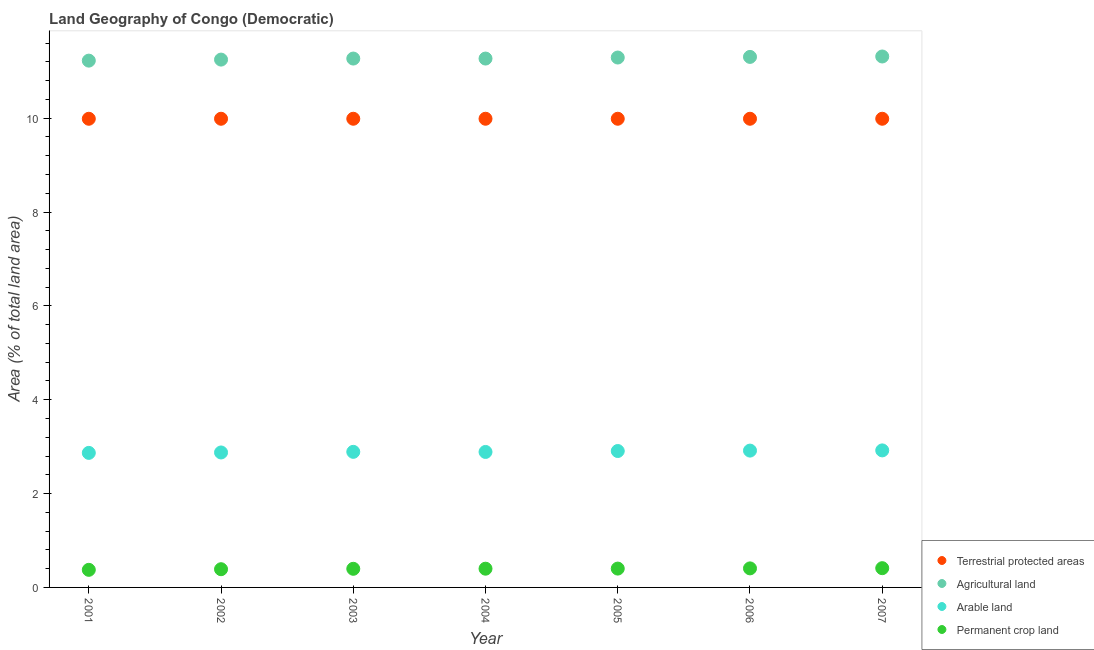What is the percentage of area under arable land in 2002?
Provide a short and direct response. 2.88. Across all years, what is the maximum percentage of area under agricultural land?
Give a very brief answer. 11.31. Across all years, what is the minimum percentage of area under agricultural land?
Offer a terse response. 11.23. In which year was the percentage of land under terrestrial protection maximum?
Provide a short and direct response. 2002. In which year was the percentage of area under agricultural land minimum?
Give a very brief answer. 2001. What is the total percentage of area under agricultural land in the graph?
Keep it short and to the point. 78.93. What is the difference between the percentage of land under terrestrial protection in 2001 and that in 2007?
Your response must be concise. -0. What is the difference between the percentage of land under terrestrial protection in 2006 and the percentage of area under permanent crop land in 2005?
Offer a terse response. 9.59. What is the average percentage of land under terrestrial protection per year?
Your response must be concise. 9.99. In the year 2003, what is the difference between the percentage of land under terrestrial protection and percentage of area under permanent crop land?
Provide a succinct answer. 9.59. In how many years, is the percentage of area under permanent crop land greater than 10 %?
Keep it short and to the point. 0. What is the ratio of the percentage of area under permanent crop land in 2002 to that in 2007?
Provide a short and direct response. 0.95. Is the difference between the percentage of area under agricultural land in 2003 and 2006 greater than the difference between the percentage of land under terrestrial protection in 2003 and 2006?
Offer a very short reply. No. What is the difference between the highest and the second highest percentage of area under agricultural land?
Ensure brevity in your answer.  0.01. What is the difference between the highest and the lowest percentage of area under agricultural land?
Your answer should be compact. 0.09. Is the sum of the percentage of area under arable land in 2003 and 2007 greater than the maximum percentage of area under agricultural land across all years?
Make the answer very short. No. Does the percentage of area under arable land monotonically increase over the years?
Offer a very short reply. No. Is the percentage of area under agricultural land strictly less than the percentage of land under terrestrial protection over the years?
Give a very brief answer. No. Are the values on the major ticks of Y-axis written in scientific E-notation?
Provide a succinct answer. No. Does the graph contain any zero values?
Your answer should be very brief. No. Does the graph contain grids?
Provide a succinct answer. No. Where does the legend appear in the graph?
Keep it short and to the point. Bottom right. How are the legend labels stacked?
Provide a short and direct response. Vertical. What is the title of the graph?
Keep it short and to the point. Land Geography of Congo (Democratic). What is the label or title of the Y-axis?
Provide a succinct answer. Area (% of total land area). What is the Area (% of total land area) of Terrestrial protected areas in 2001?
Offer a very short reply. 9.99. What is the Area (% of total land area) in Agricultural land in 2001?
Provide a succinct answer. 11.23. What is the Area (% of total land area) of Arable land in 2001?
Provide a short and direct response. 2.87. What is the Area (% of total land area) in Permanent crop land in 2001?
Ensure brevity in your answer.  0.37. What is the Area (% of total land area) in Terrestrial protected areas in 2002?
Provide a short and direct response. 9.99. What is the Area (% of total land area) in Agricultural land in 2002?
Offer a terse response. 11.25. What is the Area (% of total land area) of Arable land in 2002?
Give a very brief answer. 2.88. What is the Area (% of total land area) in Permanent crop land in 2002?
Your response must be concise. 0.39. What is the Area (% of total land area) in Terrestrial protected areas in 2003?
Provide a short and direct response. 9.99. What is the Area (% of total land area) in Agricultural land in 2003?
Make the answer very short. 11.27. What is the Area (% of total land area) in Arable land in 2003?
Offer a very short reply. 2.89. What is the Area (% of total land area) in Permanent crop land in 2003?
Your response must be concise. 0.4. What is the Area (% of total land area) of Terrestrial protected areas in 2004?
Your answer should be very brief. 9.99. What is the Area (% of total land area) of Agricultural land in 2004?
Make the answer very short. 11.27. What is the Area (% of total land area) in Arable land in 2004?
Your answer should be very brief. 2.89. What is the Area (% of total land area) of Permanent crop land in 2004?
Your answer should be very brief. 0.4. What is the Area (% of total land area) of Terrestrial protected areas in 2005?
Offer a very short reply. 9.99. What is the Area (% of total land area) of Agricultural land in 2005?
Your answer should be compact. 11.29. What is the Area (% of total land area) in Arable land in 2005?
Make the answer very short. 2.91. What is the Area (% of total land area) in Permanent crop land in 2005?
Provide a short and direct response. 0.4. What is the Area (% of total land area) of Terrestrial protected areas in 2006?
Make the answer very short. 9.99. What is the Area (% of total land area) of Agricultural land in 2006?
Provide a succinct answer. 11.31. What is the Area (% of total land area) of Arable land in 2006?
Offer a very short reply. 2.92. What is the Area (% of total land area) in Permanent crop land in 2006?
Make the answer very short. 0.41. What is the Area (% of total land area) in Terrestrial protected areas in 2007?
Provide a short and direct response. 9.99. What is the Area (% of total land area) of Agricultural land in 2007?
Give a very brief answer. 11.31. What is the Area (% of total land area) of Arable land in 2007?
Offer a very short reply. 2.92. What is the Area (% of total land area) in Permanent crop land in 2007?
Ensure brevity in your answer.  0.41. Across all years, what is the maximum Area (% of total land area) in Terrestrial protected areas?
Provide a succinct answer. 9.99. Across all years, what is the maximum Area (% of total land area) in Agricultural land?
Provide a succinct answer. 11.31. Across all years, what is the maximum Area (% of total land area) in Arable land?
Give a very brief answer. 2.92. Across all years, what is the maximum Area (% of total land area) in Permanent crop land?
Offer a very short reply. 0.41. Across all years, what is the minimum Area (% of total land area) of Terrestrial protected areas?
Your answer should be very brief. 9.99. Across all years, what is the minimum Area (% of total land area) in Agricultural land?
Ensure brevity in your answer.  11.23. Across all years, what is the minimum Area (% of total land area) in Arable land?
Keep it short and to the point. 2.87. Across all years, what is the minimum Area (% of total land area) of Permanent crop land?
Offer a terse response. 0.37. What is the total Area (% of total land area) in Terrestrial protected areas in the graph?
Provide a short and direct response. 69.91. What is the total Area (% of total land area) in Agricultural land in the graph?
Ensure brevity in your answer.  78.93. What is the total Area (% of total land area) of Arable land in the graph?
Your response must be concise. 20.26. What is the total Area (% of total land area) of Permanent crop land in the graph?
Keep it short and to the point. 2.78. What is the difference between the Area (% of total land area) of Terrestrial protected areas in 2001 and that in 2002?
Offer a very short reply. -0. What is the difference between the Area (% of total land area) in Agricultural land in 2001 and that in 2002?
Offer a terse response. -0.02. What is the difference between the Area (% of total land area) in Arable land in 2001 and that in 2002?
Give a very brief answer. -0.01. What is the difference between the Area (% of total land area) in Permanent crop land in 2001 and that in 2002?
Give a very brief answer. -0.01. What is the difference between the Area (% of total land area) in Terrestrial protected areas in 2001 and that in 2003?
Make the answer very short. -0. What is the difference between the Area (% of total land area) in Agricultural land in 2001 and that in 2003?
Give a very brief answer. -0.04. What is the difference between the Area (% of total land area) of Arable land in 2001 and that in 2003?
Keep it short and to the point. -0.02. What is the difference between the Area (% of total land area) in Permanent crop land in 2001 and that in 2003?
Make the answer very short. -0.02. What is the difference between the Area (% of total land area) of Terrestrial protected areas in 2001 and that in 2004?
Your answer should be compact. -0. What is the difference between the Area (% of total land area) of Agricultural land in 2001 and that in 2004?
Your answer should be compact. -0.04. What is the difference between the Area (% of total land area) of Arable land in 2001 and that in 2004?
Your answer should be compact. -0.02. What is the difference between the Area (% of total land area) in Permanent crop land in 2001 and that in 2004?
Keep it short and to the point. -0.02. What is the difference between the Area (% of total land area) of Terrestrial protected areas in 2001 and that in 2005?
Your response must be concise. -0. What is the difference between the Area (% of total land area) of Agricultural land in 2001 and that in 2005?
Provide a short and direct response. -0.07. What is the difference between the Area (% of total land area) of Arable land in 2001 and that in 2005?
Your answer should be very brief. -0.04. What is the difference between the Area (% of total land area) of Permanent crop land in 2001 and that in 2005?
Give a very brief answer. -0.03. What is the difference between the Area (% of total land area) in Terrestrial protected areas in 2001 and that in 2006?
Make the answer very short. -0. What is the difference between the Area (% of total land area) of Agricultural land in 2001 and that in 2006?
Your answer should be very brief. -0.08. What is the difference between the Area (% of total land area) of Arable land in 2001 and that in 2006?
Offer a very short reply. -0.05. What is the difference between the Area (% of total land area) of Permanent crop land in 2001 and that in 2006?
Your response must be concise. -0.03. What is the difference between the Area (% of total land area) of Terrestrial protected areas in 2001 and that in 2007?
Your answer should be very brief. -0. What is the difference between the Area (% of total land area) in Agricultural land in 2001 and that in 2007?
Make the answer very short. -0.09. What is the difference between the Area (% of total land area) of Arable land in 2001 and that in 2007?
Your response must be concise. -0.05. What is the difference between the Area (% of total land area) in Permanent crop land in 2001 and that in 2007?
Your answer should be compact. -0.04. What is the difference between the Area (% of total land area) in Terrestrial protected areas in 2002 and that in 2003?
Ensure brevity in your answer.  0. What is the difference between the Area (% of total land area) in Agricultural land in 2002 and that in 2003?
Your response must be concise. -0.02. What is the difference between the Area (% of total land area) of Arable land in 2002 and that in 2003?
Your response must be concise. -0.01. What is the difference between the Area (% of total land area) in Permanent crop land in 2002 and that in 2003?
Your answer should be very brief. -0.01. What is the difference between the Area (% of total land area) in Terrestrial protected areas in 2002 and that in 2004?
Provide a short and direct response. 0. What is the difference between the Area (% of total land area) of Agricultural land in 2002 and that in 2004?
Give a very brief answer. -0.02. What is the difference between the Area (% of total land area) of Arable land in 2002 and that in 2004?
Provide a succinct answer. -0.01. What is the difference between the Area (% of total land area) of Permanent crop land in 2002 and that in 2004?
Give a very brief answer. -0.01. What is the difference between the Area (% of total land area) in Agricultural land in 2002 and that in 2005?
Make the answer very short. -0.04. What is the difference between the Area (% of total land area) of Arable land in 2002 and that in 2005?
Ensure brevity in your answer.  -0.03. What is the difference between the Area (% of total land area) of Permanent crop land in 2002 and that in 2005?
Offer a terse response. -0.01. What is the difference between the Area (% of total land area) of Terrestrial protected areas in 2002 and that in 2006?
Your response must be concise. 0. What is the difference between the Area (% of total land area) in Agricultural land in 2002 and that in 2006?
Provide a short and direct response. -0.06. What is the difference between the Area (% of total land area) of Arable land in 2002 and that in 2006?
Provide a short and direct response. -0.04. What is the difference between the Area (% of total land area) in Permanent crop land in 2002 and that in 2006?
Your answer should be compact. -0.02. What is the difference between the Area (% of total land area) in Terrestrial protected areas in 2002 and that in 2007?
Ensure brevity in your answer.  0. What is the difference between the Area (% of total land area) of Agricultural land in 2002 and that in 2007?
Ensure brevity in your answer.  -0.07. What is the difference between the Area (% of total land area) in Arable land in 2002 and that in 2007?
Your answer should be compact. -0.04. What is the difference between the Area (% of total land area) of Permanent crop land in 2002 and that in 2007?
Make the answer very short. -0.02. What is the difference between the Area (% of total land area) in Arable land in 2003 and that in 2004?
Offer a very short reply. 0. What is the difference between the Area (% of total land area) in Permanent crop land in 2003 and that in 2004?
Your response must be concise. -0. What is the difference between the Area (% of total land area) of Agricultural land in 2003 and that in 2005?
Offer a very short reply. -0.02. What is the difference between the Area (% of total land area) in Arable land in 2003 and that in 2005?
Keep it short and to the point. -0.02. What is the difference between the Area (% of total land area) of Permanent crop land in 2003 and that in 2005?
Make the answer very short. -0. What is the difference between the Area (% of total land area) of Terrestrial protected areas in 2003 and that in 2006?
Offer a terse response. 0. What is the difference between the Area (% of total land area) in Agricultural land in 2003 and that in 2006?
Offer a terse response. -0.04. What is the difference between the Area (% of total land area) in Arable land in 2003 and that in 2006?
Keep it short and to the point. -0.03. What is the difference between the Area (% of total land area) of Permanent crop land in 2003 and that in 2006?
Make the answer very short. -0.01. What is the difference between the Area (% of total land area) of Terrestrial protected areas in 2003 and that in 2007?
Keep it short and to the point. 0. What is the difference between the Area (% of total land area) in Agricultural land in 2003 and that in 2007?
Offer a very short reply. -0.04. What is the difference between the Area (% of total land area) of Arable land in 2003 and that in 2007?
Your answer should be compact. -0.03. What is the difference between the Area (% of total land area) of Permanent crop land in 2003 and that in 2007?
Offer a terse response. -0.01. What is the difference between the Area (% of total land area) of Terrestrial protected areas in 2004 and that in 2005?
Your response must be concise. 0. What is the difference between the Area (% of total land area) in Agricultural land in 2004 and that in 2005?
Your response must be concise. -0.02. What is the difference between the Area (% of total land area) in Arable land in 2004 and that in 2005?
Your answer should be very brief. -0.02. What is the difference between the Area (% of total land area) in Permanent crop land in 2004 and that in 2005?
Ensure brevity in your answer.  -0. What is the difference between the Area (% of total land area) in Agricultural land in 2004 and that in 2006?
Provide a succinct answer. -0.04. What is the difference between the Area (% of total land area) in Arable land in 2004 and that in 2006?
Provide a short and direct response. -0.03. What is the difference between the Area (% of total land area) of Permanent crop land in 2004 and that in 2006?
Provide a succinct answer. -0.01. What is the difference between the Area (% of total land area) in Terrestrial protected areas in 2004 and that in 2007?
Provide a succinct answer. 0. What is the difference between the Area (% of total land area) of Agricultural land in 2004 and that in 2007?
Your answer should be compact. -0.04. What is the difference between the Area (% of total land area) in Arable land in 2004 and that in 2007?
Your response must be concise. -0.03. What is the difference between the Area (% of total land area) in Permanent crop land in 2004 and that in 2007?
Provide a short and direct response. -0.01. What is the difference between the Area (% of total land area) in Terrestrial protected areas in 2005 and that in 2006?
Your response must be concise. 0. What is the difference between the Area (% of total land area) in Agricultural land in 2005 and that in 2006?
Keep it short and to the point. -0.01. What is the difference between the Area (% of total land area) of Arable land in 2005 and that in 2006?
Offer a very short reply. -0.01. What is the difference between the Area (% of total land area) of Permanent crop land in 2005 and that in 2006?
Your answer should be compact. -0. What is the difference between the Area (% of total land area) of Terrestrial protected areas in 2005 and that in 2007?
Keep it short and to the point. 0. What is the difference between the Area (% of total land area) of Agricultural land in 2005 and that in 2007?
Offer a very short reply. -0.02. What is the difference between the Area (% of total land area) in Arable land in 2005 and that in 2007?
Give a very brief answer. -0.01. What is the difference between the Area (% of total land area) of Permanent crop land in 2005 and that in 2007?
Offer a terse response. -0.01. What is the difference between the Area (% of total land area) of Terrestrial protected areas in 2006 and that in 2007?
Keep it short and to the point. 0. What is the difference between the Area (% of total land area) in Agricultural land in 2006 and that in 2007?
Provide a short and direct response. -0.01. What is the difference between the Area (% of total land area) in Arable land in 2006 and that in 2007?
Your answer should be compact. -0. What is the difference between the Area (% of total land area) of Permanent crop land in 2006 and that in 2007?
Make the answer very short. -0. What is the difference between the Area (% of total land area) of Terrestrial protected areas in 2001 and the Area (% of total land area) of Agricultural land in 2002?
Keep it short and to the point. -1.26. What is the difference between the Area (% of total land area) in Terrestrial protected areas in 2001 and the Area (% of total land area) in Arable land in 2002?
Make the answer very short. 7.11. What is the difference between the Area (% of total land area) of Terrestrial protected areas in 2001 and the Area (% of total land area) of Permanent crop land in 2002?
Offer a very short reply. 9.6. What is the difference between the Area (% of total land area) in Agricultural land in 2001 and the Area (% of total land area) in Arable land in 2002?
Make the answer very short. 8.35. What is the difference between the Area (% of total land area) of Agricultural land in 2001 and the Area (% of total land area) of Permanent crop land in 2002?
Offer a terse response. 10.84. What is the difference between the Area (% of total land area) of Arable land in 2001 and the Area (% of total land area) of Permanent crop land in 2002?
Provide a succinct answer. 2.48. What is the difference between the Area (% of total land area) of Terrestrial protected areas in 2001 and the Area (% of total land area) of Agricultural land in 2003?
Provide a succinct answer. -1.28. What is the difference between the Area (% of total land area) of Terrestrial protected areas in 2001 and the Area (% of total land area) of Arable land in 2003?
Your response must be concise. 7.1. What is the difference between the Area (% of total land area) of Terrestrial protected areas in 2001 and the Area (% of total land area) of Permanent crop land in 2003?
Your response must be concise. 9.59. What is the difference between the Area (% of total land area) of Agricultural land in 2001 and the Area (% of total land area) of Arable land in 2003?
Keep it short and to the point. 8.34. What is the difference between the Area (% of total land area) of Agricultural land in 2001 and the Area (% of total land area) of Permanent crop land in 2003?
Offer a terse response. 10.83. What is the difference between the Area (% of total land area) in Arable land in 2001 and the Area (% of total land area) in Permanent crop land in 2003?
Give a very brief answer. 2.47. What is the difference between the Area (% of total land area) in Terrestrial protected areas in 2001 and the Area (% of total land area) in Agricultural land in 2004?
Make the answer very short. -1.28. What is the difference between the Area (% of total land area) in Terrestrial protected areas in 2001 and the Area (% of total land area) in Arable land in 2004?
Ensure brevity in your answer.  7.1. What is the difference between the Area (% of total land area) of Terrestrial protected areas in 2001 and the Area (% of total land area) of Permanent crop land in 2004?
Provide a succinct answer. 9.59. What is the difference between the Area (% of total land area) in Agricultural land in 2001 and the Area (% of total land area) in Arable land in 2004?
Keep it short and to the point. 8.34. What is the difference between the Area (% of total land area) in Agricultural land in 2001 and the Area (% of total land area) in Permanent crop land in 2004?
Your answer should be compact. 10.83. What is the difference between the Area (% of total land area) of Arable land in 2001 and the Area (% of total land area) of Permanent crop land in 2004?
Your response must be concise. 2.47. What is the difference between the Area (% of total land area) of Terrestrial protected areas in 2001 and the Area (% of total land area) of Agricultural land in 2005?
Offer a very short reply. -1.31. What is the difference between the Area (% of total land area) in Terrestrial protected areas in 2001 and the Area (% of total land area) in Arable land in 2005?
Your answer should be compact. 7.08. What is the difference between the Area (% of total land area) of Terrestrial protected areas in 2001 and the Area (% of total land area) of Permanent crop land in 2005?
Offer a terse response. 9.59. What is the difference between the Area (% of total land area) of Agricultural land in 2001 and the Area (% of total land area) of Arable land in 2005?
Provide a succinct answer. 8.32. What is the difference between the Area (% of total land area) of Agricultural land in 2001 and the Area (% of total land area) of Permanent crop land in 2005?
Make the answer very short. 10.82. What is the difference between the Area (% of total land area) in Arable land in 2001 and the Area (% of total land area) in Permanent crop land in 2005?
Make the answer very short. 2.47. What is the difference between the Area (% of total land area) of Terrestrial protected areas in 2001 and the Area (% of total land area) of Agricultural land in 2006?
Offer a very short reply. -1.32. What is the difference between the Area (% of total land area) of Terrestrial protected areas in 2001 and the Area (% of total land area) of Arable land in 2006?
Your answer should be compact. 7.07. What is the difference between the Area (% of total land area) in Terrestrial protected areas in 2001 and the Area (% of total land area) in Permanent crop land in 2006?
Your answer should be very brief. 9.58. What is the difference between the Area (% of total land area) of Agricultural land in 2001 and the Area (% of total land area) of Arable land in 2006?
Provide a short and direct response. 8.31. What is the difference between the Area (% of total land area) in Agricultural land in 2001 and the Area (% of total land area) in Permanent crop land in 2006?
Your answer should be very brief. 10.82. What is the difference between the Area (% of total land area) of Arable land in 2001 and the Area (% of total land area) of Permanent crop land in 2006?
Keep it short and to the point. 2.46. What is the difference between the Area (% of total land area) of Terrestrial protected areas in 2001 and the Area (% of total land area) of Agricultural land in 2007?
Ensure brevity in your answer.  -1.33. What is the difference between the Area (% of total land area) of Terrestrial protected areas in 2001 and the Area (% of total land area) of Arable land in 2007?
Give a very brief answer. 7.07. What is the difference between the Area (% of total land area) in Terrestrial protected areas in 2001 and the Area (% of total land area) in Permanent crop land in 2007?
Offer a terse response. 9.58. What is the difference between the Area (% of total land area) in Agricultural land in 2001 and the Area (% of total land area) in Arable land in 2007?
Provide a short and direct response. 8.31. What is the difference between the Area (% of total land area) of Agricultural land in 2001 and the Area (% of total land area) of Permanent crop land in 2007?
Ensure brevity in your answer.  10.82. What is the difference between the Area (% of total land area) of Arable land in 2001 and the Area (% of total land area) of Permanent crop land in 2007?
Your response must be concise. 2.46. What is the difference between the Area (% of total land area) in Terrestrial protected areas in 2002 and the Area (% of total land area) in Agricultural land in 2003?
Provide a short and direct response. -1.28. What is the difference between the Area (% of total land area) in Terrestrial protected areas in 2002 and the Area (% of total land area) in Arable land in 2003?
Provide a short and direct response. 7.1. What is the difference between the Area (% of total land area) of Terrestrial protected areas in 2002 and the Area (% of total land area) of Permanent crop land in 2003?
Make the answer very short. 9.59. What is the difference between the Area (% of total land area) of Agricultural land in 2002 and the Area (% of total land area) of Arable land in 2003?
Provide a succinct answer. 8.36. What is the difference between the Area (% of total land area) of Agricultural land in 2002 and the Area (% of total land area) of Permanent crop land in 2003?
Keep it short and to the point. 10.85. What is the difference between the Area (% of total land area) in Arable land in 2002 and the Area (% of total land area) in Permanent crop land in 2003?
Keep it short and to the point. 2.48. What is the difference between the Area (% of total land area) in Terrestrial protected areas in 2002 and the Area (% of total land area) in Agricultural land in 2004?
Your response must be concise. -1.28. What is the difference between the Area (% of total land area) of Terrestrial protected areas in 2002 and the Area (% of total land area) of Arable land in 2004?
Your answer should be compact. 7.1. What is the difference between the Area (% of total land area) in Terrestrial protected areas in 2002 and the Area (% of total land area) in Permanent crop land in 2004?
Offer a terse response. 9.59. What is the difference between the Area (% of total land area) of Agricultural land in 2002 and the Area (% of total land area) of Arable land in 2004?
Offer a very short reply. 8.36. What is the difference between the Area (% of total land area) of Agricultural land in 2002 and the Area (% of total land area) of Permanent crop land in 2004?
Offer a terse response. 10.85. What is the difference between the Area (% of total land area) in Arable land in 2002 and the Area (% of total land area) in Permanent crop land in 2004?
Your response must be concise. 2.48. What is the difference between the Area (% of total land area) of Terrestrial protected areas in 2002 and the Area (% of total land area) of Agricultural land in 2005?
Provide a succinct answer. -1.3. What is the difference between the Area (% of total land area) in Terrestrial protected areas in 2002 and the Area (% of total land area) in Arable land in 2005?
Provide a succinct answer. 7.08. What is the difference between the Area (% of total land area) of Terrestrial protected areas in 2002 and the Area (% of total land area) of Permanent crop land in 2005?
Make the answer very short. 9.59. What is the difference between the Area (% of total land area) of Agricultural land in 2002 and the Area (% of total land area) of Arable land in 2005?
Ensure brevity in your answer.  8.34. What is the difference between the Area (% of total land area) in Agricultural land in 2002 and the Area (% of total land area) in Permanent crop land in 2005?
Keep it short and to the point. 10.85. What is the difference between the Area (% of total land area) of Arable land in 2002 and the Area (% of total land area) of Permanent crop land in 2005?
Provide a short and direct response. 2.47. What is the difference between the Area (% of total land area) in Terrestrial protected areas in 2002 and the Area (% of total land area) in Agricultural land in 2006?
Your response must be concise. -1.32. What is the difference between the Area (% of total land area) of Terrestrial protected areas in 2002 and the Area (% of total land area) of Arable land in 2006?
Provide a succinct answer. 7.07. What is the difference between the Area (% of total land area) in Terrestrial protected areas in 2002 and the Area (% of total land area) in Permanent crop land in 2006?
Your answer should be compact. 9.58. What is the difference between the Area (% of total land area) of Agricultural land in 2002 and the Area (% of total land area) of Arable land in 2006?
Make the answer very short. 8.33. What is the difference between the Area (% of total land area) of Agricultural land in 2002 and the Area (% of total land area) of Permanent crop land in 2006?
Provide a short and direct response. 10.84. What is the difference between the Area (% of total land area) in Arable land in 2002 and the Area (% of total land area) in Permanent crop land in 2006?
Ensure brevity in your answer.  2.47. What is the difference between the Area (% of total land area) of Terrestrial protected areas in 2002 and the Area (% of total land area) of Agricultural land in 2007?
Offer a very short reply. -1.33. What is the difference between the Area (% of total land area) of Terrestrial protected areas in 2002 and the Area (% of total land area) of Arable land in 2007?
Keep it short and to the point. 7.07. What is the difference between the Area (% of total land area) in Terrestrial protected areas in 2002 and the Area (% of total land area) in Permanent crop land in 2007?
Offer a very short reply. 9.58. What is the difference between the Area (% of total land area) in Agricultural land in 2002 and the Area (% of total land area) in Arable land in 2007?
Ensure brevity in your answer.  8.33. What is the difference between the Area (% of total land area) of Agricultural land in 2002 and the Area (% of total land area) of Permanent crop land in 2007?
Give a very brief answer. 10.84. What is the difference between the Area (% of total land area) in Arable land in 2002 and the Area (% of total land area) in Permanent crop land in 2007?
Offer a terse response. 2.47. What is the difference between the Area (% of total land area) in Terrestrial protected areas in 2003 and the Area (% of total land area) in Agricultural land in 2004?
Keep it short and to the point. -1.28. What is the difference between the Area (% of total land area) in Terrestrial protected areas in 2003 and the Area (% of total land area) in Arable land in 2004?
Your response must be concise. 7.1. What is the difference between the Area (% of total land area) in Terrestrial protected areas in 2003 and the Area (% of total land area) in Permanent crop land in 2004?
Offer a very short reply. 9.59. What is the difference between the Area (% of total land area) in Agricultural land in 2003 and the Area (% of total land area) in Arable land in 2004?
Your answer should be compact. 8.38. What is the difference between the Area (% of total land area) in Agricultural land in 2003 and the Area (% of total land area) in Permanent crop land in 2004?
Provide a succinct answer. 10.87. What is the difference between the Area (% of total land area) of Arable land in 2003 and the Area (% of total land area) of Permanent crop land in 2004?
Your answer should be very brief. 2.49. What is the difference between the Area (% of total land area) in Terrestrial protected areas in 2003 and the Area (% of total land area) in Agricultural land in 2005?
Provide a succinct answer. -1.3. What is the difference between the Area (% of total land area) in Terrestrial protected areas in 2003 and the Area (% of total land area) in Arable land in 2005?
Offer a very short reply. 7.08. What is the difference between the Area (% of total land area) of Terrestrial protected areas in 2003 and the Area (% of total land area) of Permanent crop land in 2005?
Make the answer very short. 9.59. What is the difference between the Area (% of total land area) of Agricultural land in 2003 and the Area (% of total land area) of Arable land in 2005?
Keep it short and to the point. 8.36. What is the difference between the Area (% of total land area) of Agricultural land in 2003 and the Area (% of total land area) of Permanent crop land in 2005?
Offer a terse response. 10.87. What is the difference between the Area (% of total land area) in Arable land in 2003 and the Area (% of total land area) in Permanent crop land in 2005?
Ensure brevity in your answer.  2.49. What is the difference between the Area (% of total land area) of Terrestrial protected areas in 2003 and the Area (% of total land area) of Agricultural land in 2006?
Your answer should be very brief. -1.32. What is the difference between the Area (% of total land area) of Terrestrial protected areas in 2003 and the Area (% of total land area) of Arable land in 2006?
Give a very brief answer. 7.07. What is the difference between the Area (% of total land area) of Terrestrial protected areas in 2003 and the Area (% of total land area) of Permanent crop land in 2006?
Keep it short and to the point. 9.58. What is the difference between the Area (% of total land area) in Agricultural land in 2003 and the Area (% of total land area) in Arable land in 2006?
Offer a terse response. 8.35. What is the difference between the Area (% of total land area) of Agricultural land in 2003 and the Area (% of total land area) of Permanent crop land in 2006?
Keep it short and to the point. 10.86. What is the difference between the Area (% of total land area) of Arable land in 2003 and the Area (% of total land area) of Permanent crop land in 2006?
Offer a terse response. 2.48. What is the difference between the Area (% of total land area) of Terrestrial protected areas in 2003 and the Area (% of total land area) of Agricultural land in 2007?
Offer a very short reply. -1.33. What is the difference between the Area (% of total land area) in Terrestrial protected areas in 2003 and the Area (% of total land area) in Arable land in 2007?
Your answer should be very brief. 7.07. What is the difference between the Area (% of total land area) in Terrestrial protected areas in 2003 and the Area (% of total land area) in Permanent crop land in 2007?
Ensure brevity in your answer.  9.58. What is the difference between the Area (% of total land area) in Agricultural land in 2003 and the Area (% of total land area) in Arable land in 2007?
Provide a short and direct response. 8.35. What is the difference between the Area (% of total land area) in Agricultural land in 2003 and the Area (% of total land area) in Permanent crop land in 2007?
Ensure brevity in your answer.  10.86. What is the difference between the Area (% of total land area) in Arable land in 2003 and the Area (% of total land area) in Permanent crop land in 2007?
Your answer should be very brief. 2.48. What is the difference between the Area (% of total land area) in Terrestrial protected areas in 2004 and the Area (% of total land area) in Agricultural land in 2005?
Offer a terse response. -1.3. What is the difference between the Area (% of total land area) in Terrestrial protected areas in 2004 and the Area (% of total land area) in Arable land in 2005?
Offer a very short reply. 7.08. What is the difference between the Area (% of total land area) in Terrestrial protected areas in 2004 and the Area (% of total land area) in Permanent crop land in 2005?
Offer a terse response. 9.59. What is the difference between the Area (% of total land area) of Agricultural land in 2004 and the Area (% of total land area) of Arable land in 2005?
Provide a succinct answer. 8.36. What is the difference between the Area (% of total land area) in Agricultural land in 2004 and the Area (% of total land area) in Permanent crop land in 2005?
Offer a terse response. 10.87. What is the difference between the Area (% of total land area) of Arable land in 2004 and the Area (% of total land area) of Permanent crop land in 2005?
Provide a short and direct response. 2.49. What is the difference between the Area (% of total land area) of Terrestrial protected areas in 2004 and the Area (% of total land area) of Agricultural land in 2006?
Offer a terse response. -1.32. What is the difference between the Area (% of total land area) in Terrestrial protected areas in 2004 and the Area (% of total land area) in Arable land in 2006?
Provide a succinct answer. 7.07. What is the difference between the Area (% of total land area) of Terrestrial protected areas in 2004 and the Area (% of total land area) of Permanent crop land in 2006?
Your response must be concise. 9.58. What is the difference between the Area (% of total land area) in Agricultural land in 2004 and the Area (% of total land area) in Arable land in 2006?
Offer a very short reply. 8.35. What is the difference between the Area (% of total land area) of Agricultural land in 2004 and the Area (% of total land area) of Permanent crop land in 2006?
Provide a short and direct response. 10.86. What is the difference between the Area (% of total land area) of Arable land in 2004 and the Area (% of total land area) of Permanent crop land in 2006?
Provide a short and direct response. 2.48. What is the difference between the Area (% of total land area) in Terrestrial protected areas in 2004 and the Area (% of total land area) in Agricultural land in 2007?
Your answer should be very brief. -1.33. What is the difference between the Area (% of total land area) of Terrestrial protected areas in 2004 and the Area (% of total land area) of Arable land in 2007?
Offer a very short reply. 7.07. What is the difference between the Area (% of total land area) of Terrestrial protected areas in 2004 and the Area (% of total land area) of Permanent crop land in 2007?
Keep it short and to the point. 9.58. What is the difference between the Area (% of total land area) of Agricultural land in 2004 and the Area (% of total land area) of Arable land in 2007?
Give a very brief answer. 8.35. What is the difference between the Area (% of total land area) of Agricultural land in 2004 and the Area (% of total land area) of Permanent crop land in 2007?
Ensure brevity in your answer.  10.86. What is the difference between the Area (% of total land area) in Arable land in 2004 and the Area (% of total land area) in Permanent crop land in 2007?
Keep it short and to the point. 2.48. What is the difference between the Area (% of total land area) in Terrestrial protected areas in 2005 and the Area (% of total land area) in Agricultural land in 2006?
Your response must be concise. -1.32. What is the difference between the Area (% of total land area) in Terrestrial protected areas in 2005 and the Area (% of total land area) in Arable land in 2006?
Ensure brevity in your answer.  7.07. What is the difference between the Area (% of total land area) of Terrestrial protected areas in 2005 and the Area (% of total land area) of Permanent crop land in 2006?
Keep it short and to the point. 9.58. What is the difference between the Area (% of total land area) of Agricultural land in 2005 and the Area (% of total land area) of Arable land in 2006?
Give a very brief answer. 8.38. What is the difference between the Area (% of total land area) in Agricultural land in 2005 and the Area (% of total land area) in Permanent crop land in 2006?
Offer a very short reply. 10.89. What is the difference between the Area (% of total land area) in Arable land in 2005 and the Area (% of total land area) in Permanent crop land in 2006?
Make the answer very short. 2.5. What is the difference between the Area (% of total land area) in Terrestrial protected areas in 2005 and the Area (% of total land area) in Agricultural land in 2007?
Offer a terse response. -1.33. What is the difference between the Area (% of total land area) of Terrestrial protected areas in 2005 and the Area (% of total land area) of Arable land in 2007?
Offer a very short reply. 7.07. What is the difference between the Area (% of total land area) of Terrestrial protected areas in 2005 and the Area (% of total land area) of Permanent crop land in 2007?
Your answer should be very brief. 9.58. What is the difference between the Area (% of total land area) in Agricultural land in 2005 and the Area (% of total land area) in Arable land in 2007?
Your answer should be very brief. 8.37. What is the difference between the Area (% of total land area) in Agricultural land in 2005 and the Area (% of total land area) in Permanent crop land in 2007?
Offer a very short reply. 10.88. What is the difference between the Area (% of total land area) in Arable land in 2005 and the Area (% of total land area) in Permanent crop land in 2007?
Provide a succinct answer. 2.5. What is the difference between the Area (% of total land area) in Terrestrial protected areas in 2006 and the Area (% of total land area) in Agricultural land in 2007?
Your answer should be compact. -1.33. What is the difference between the Area (% of total land area) of Terrestrial protected areas in 2006 and the Area (% of total land area) of Arable land in 2007?
Offer a terse response. 7.07. What is the difference between the Area (% of total land area) of Terrestrial protected areas in 2006 and the Area (% of total land area) of Permanent crop land in 2007?
Offer a terse response. 9.58. What is the difference between the Area (% of total land area) of Agricultural land in 2006 and the Area (% of total land area) of Arable land in 2007?
Give a very brief answer. 8.39. What is the difference between the Area (% of total land area) of Agricultural land in 2006 and the Area (% of total land area) of Permanent crop land in 2007?
Ensure brevity in your answer.  10.9. What is the difference between the Area (% of total land area) in Arable land in 2006 and the Area (% of total land area) in Permanent crop land in 2007?
Keep it short and to the point. 2.51. What is the average Area (% of total land area) in Terrestrial protected areas per year?
Offer a terse response. 9.99. What is the average Area (% of total land area) of Agricultural land per year?
Your answer should be compact. 11.28. What is the average Area (% of total land area) of Arable land per year?
Your answer should be compact. 2.89. What is the average Area (% of total land area) of Permanent crop land per year?
Offer a terse response. 0.4. In the year 2001, what is the difference between the Area (% of total land area) in Terrestrial protected areas and Area (% of total land area) in Agricultural land?
Give a very brief answer. -1.24. In the year 2001, what is the difference between the Area (% of total land area) of Terrestrial protected areas and Area (% of total land area) of Arable land?
Your answer should be very brief. 7.12. In the year 2001, what is the difference between the Area (% of total land area) of Terrestrial protected areas and Area (% of total land area) of Permanent crop land?
Provide a short and direct response. 9.61. In the year 2001, what is the difference between the Area (% of total land area) of Agricultural land and Area (% of total land area) of Arable land?
Provide a succinct answer. 8.36. In the year 2001, what is the difference between the Area (% of total land area) in Agricultural land and Area (% of total land area) in Permanent crop land?
Your response must be concise. 10.85. In the year 2001, what is the difference between the Area (% of total land area) of Arable land and Area (% of total land area) of Permanent crop land?
Ensure brevity in your answer.  2.49. In the year 2002, what is the difference between the Area (% of total land area) in Terrestrial protected areas and Area (% of total land area) in Agricultural land?
Provide a succinct answer. -1.26. In the year 2002, what is the difference between the Area (% of total land area) of Terrestrial protected areas and Area (% of total land area) of Arable land?
Give a very brief answer. 7.11. In the year 2002, what is the difference between the Area (% of total land area) in Terrestrial protected areas and Area (% of total land area) in Permanent crop land?
Offer a terse response. 9.6. In the year 2002, what is the difference between the Area (% of total land area) of Agricultural land and Area (% of total land area) of Arable land?
Your response must be concise. 8.37. In the year 2002, what is the difference between the Area (% of total land area) in Agricultural land and Area (% of total land area) in Permanent crop land?
Your answer should be compact. 10.86. In the year 2002, what is the difference between the Area (% of total land area) in Arable land and Area (% of total land area) in Permanent crop land?
Make the answer very short. 2.49. In the year 2003, what is the difference between the Area (% of total land area) in Terrestrial protected areas and Area (% of total land area) in Agricultural land?
Provide a short and direct response. -1.28. In the year 2003, what is the difference between the Area (% of total land area) of Terrestrial protected areas and Area (% of total land area) of Arable land?
Offer a very short reply. 7.1. In the year 2003, what is the difference between the Area (% of total land area) in Terrestrial protected areas and Area (% of total land area) in Permanent crop land?
Offer a terse response. 9.59. In the year 2003, what is the difference between the Area (% of total land area) in Agricultural land and Area (% of total land area) in Arable land?
Keep it short and to the point. 8.38. In the year 2003, what is the difference between the Area (% of total land area) in Agricultural land and Area (% of total land area) in Permanent crop land?
Ensure brevity in your answer.  10.87. In the year 2003, what is the difference between the Area (% of total land area) in Arable land and Area (% of total land area) in Permanent crop land?
Ensure brevity in your answer.  2.49. In the year 2004, what is the difference between the Area (% of total land area) of Terrestrial protected areas and Area (% of total land area) of Agricultural land?
Provide a short and direct response. -1.28. In the year 2004, what is the difference between the Area (% of total land area) in Terrestrial protected areas and Area (% of total land area) in Arable land?
Provide a succinct answer. 7.1. In the year 2004, what is the difference between the Area (% of total land area) of Terrestrial protected areas and Area (% of total land area) of Permanent crop land?
Offer a terse response. 9.59. In the year 2004, what is the difference between the Area (% of total land area) of Agricultural land and Area (% of total land area) of Arable land?
Give a very brief answer. 8.38. In the year 2004, what is the difference between the Area (% of total land area) of Agricultural land and Area (% of total land area) of Permanent crop land?
Your response must be concise. 10.87. In the year 2004, what is the difference between the Area (% of total land area) in Arable land and Area (% of total land area) in Permanent crop land?
Your answer should be compact. 2.49. In the year 2005, what is the difference between the Area (% of total land area) in Terrestrial protected areas and Area (% of total land area) in Agricultural land?
Your answer should be compact. -1.3. In the year 2005, what is the difference between the Area (% of total land area) in Terrestrial protected areas and Area (% of total land area) in Arable land?
Provide a short and direct response. 7.08. In the year 2005, what is the difference between the Area (% of total land area) in Terrestrial protected areas and Area (% of total land area) in Permanent crop land?
Your answer should be very brief. 9.59. In the year 2005, what is the difference between the Area (% of total land area) of Agricultural land and Area (% of total land area) of Arable land?
Your answer should be very brief. 8.39. In the year 2005, what is the difference between the Area (% of total land area) of Agricultural land and Area (% of total land area) of Permanent crop land?
Provide a succinct answer. 10.89. In the year 2005, what is the difference between the Area (% of total land area) in Arable land and Area (% of total land area) in Permanent crop land?
Make the answer very short. 2.51. In the year 2006, what is the difference between the Area (% of total land area) of Terrestrial protected areas and Area (% of total land area) of Agricultural land?
Make the answer very short. -1.32. In the year 2006, what is the difference between the Area (% of total land area) of Terrestrial protected areas and Area (% of total land area) of Arable land?
Make the answer very short. 7.07. In the year 2006, what is the difference between the Area (% of total land area) in Terrestrial protected areas and Area (% of total land area) in Permanent crop land?
Your answer should be compact. 9.58. In the year 2006, what is the difference between the Area (% of total land area) in Agricultural land and Area (% of total land area) in Arable land?
Ensure brevity in your answer.  8.39. In the year 2006, what is the difference between the Area (% of total land area) in Agricultural land and Area (% of total land area) in Permanent crop land?
Provide a short and direct response. 10.9. In the year 2006, what is the difference between the Area (% of total land area) of Arable land and Area (% of total land area) of Permanent crop land?
Ensure brevity in your answer.  2.51. In the year 2007, what is the difference between the Area (% of total land area) of Terrestrial protected areas and Area (% of total land area) of Agricultural land?
Your answer should be compact. -1.33. In the year 2007, what is the difference between the Area (% of total land area) in Terrestrial protected areas and Area (% of total land area) in Arable land?
Your answer should be very brief. 7.07. In the year 2007, what is the difference between the Area (% of total land area) in Terrestrial protected areas and Area (% of total land area) in Permanent crop land?
Give a very brief answer. 9.58. In the year 2007, what is the difference between the Area (% of total land area) of Agricultural land and Area (% of total land area) of Arable land?
Keep it short and to the point. 8.39. In the year 2007, what is the difference between the Area (% of total land area) of Agricultural land and Area (% of total land area) of Permanent crop land?
Your response must be concise. 10.9. In the year 2007, what is the difference between the Area (% of total land area) of Arable land and Area (% of total land area) of Permanent crop land?
Make the answer very short. 2.51. What is the ratio of the Area (% of total land area) of Terrestrial protected areas in 2001 to that in 2002?
Provide a short and direct response. 1. What is the ratio of the Area (% of total land area) of Agricultural land in 2001 to that in 2002?
Keep it short and to the point. 1. What is the ratio of the Area (% of total land area) of Permanent crop land in 2001 to that in 2002?
Your answer should be very brief. 0.97. What is the ratio of the Area (% of total land area) in Permanent crop land in 2001 to that in 2004?
Ensure brevity in your answer.  0.94. What is the ratio of the Area (% of total land area) in Terrestrial protected areas in 2001 to that in 2005?
Provide a succinct answer. 1. What is the ratio of the Area (% of total land area) of Arable land in 2001 to that in 2005?
Your answer should be very brief. 0.99. What is the ratio of the Area (% of total land area) in Permanent crop land in 2001 to that in 2005?
Ensure brevity in your answer.  0.93. What is the ratio of the Area (% of total land area) of Arable land in 2001 to that in 2006?
Make the answer very short. 0.98. What is the ratio of the Area (% of total land area) of Permanent crop land in 2001 to that in 2006?
Keep it short and to the point. 0.92. What is the ratio of the Area (% of total land area) of Terrestrial protected areas in 2001 to that in 2007?
Provide a short and direct response. 1. What is the ratio of the Area (% of total land area) of Arable land in 2001 to that in 2007?
Provide a succinct answer. 0.98. What is the ratio of the Area (% of total land area) of Permanent crop land in 2001 to that in 2007?
Keep it short and to the point. 0.91. What is the ratio of the Area (% of total land area) in Terrestrial protected areas in 2002 to that in 2003?
Your response must be concise. 1. What is the ratio of the Area (% of total land area) of Agricultural land in 2002 to that in 2003?
Make the answer very short. 1. What is the ratio of the Area (% of total land area) in Permanent crop land in 2002 to that in 2003?
Give a very brief answer. 0.98. What is the ratio of the Area (% of total land area) in Terrestrial protected areas in 2002 to that in 2004?
Offer a very short reply. 1. What is the ratio of the Area (% of total land area) of Arable land in 2002 to that in 2004?
Your response must be concise. 1. What is the ratio of the Area (% of total land area) in Permanent crop land in 2002 to that in 2004?
Offer a terse response. 0.97. What is the ratio of the Area (% of total land area) of Terrestrial protected areas in 2002 to that in 2005?
Offer a terse response. 1. What is the ratio of the Area (% of total land area) in Terrestrial protected areas in 2002 to that in 2006?
Provide a succinct answer. 1. What is the ratio of the Area (% of total land area) in Arable land in 2002 to that in 2006?
Make the answer very short. 0.99. What is the ratio of the Area (% of total land area) of Permanent crop land in 2002 to that in 2006?
Your answer should be very brief. 0.96. What is the ratio of the Area (% of total land area) of Arable land in 2002 to that in 2007?
Offer a very short reply. 0.98. What is the ratio of the Area (% of total land area) of Permanent crop land in 2002 to that in 2007?
Your answer should be very brief. 0.95. What is the ratio of the Area (% of total land area) in Agricultural land in 2003 to that in 2004?
Ensure brevity in your answer.  1. What is the ratio of the Area (% of total land area) in Permanent crop land in 2003 to that in 2004?
Ensure brevity in your answer.  0.99. What is the ratio of the Area (% of total land area) in Arable land in 2003 to that in 2005?
Your answer should be very brief. 0.99. What is the ratio of the Area (% of total land area) in Permanent crop land in 2003 to that in 2005?
Your answer should be very brief. 0.99. What is the ratio of the Area (% of total land area) of Terrestrial protected areas in 2003 to that in 2006?
Make the answer very short. 1. What is the ratio of the Area (% of total land area) in Agricultural land in 2003 to that in 2006?
Your answer should be compact. 1. What is the ratio of the Area (% of total land area) of Arable land in 2003 to that in 2006?
Give a very brief answer. 0.99. What is the ratio of the Area (% of total land area) in Permanent crop land in 2003 to that in 2006?
Ensure brevity in your answer.  0.98. What is the ratio of the Area (% of total land area) of Arable land in 2003 to that in 2007?
Your answer should be very brief. 0.99. What is the ratio of the Area (% of total land area) in Agricultural land in 2004 to that in 2005?
Ensure brevity in your answer.  1. What is the ratio of the Area (% of total land area) in Arable land in 2004 to that in 2005?
Provide a short and direct response. 0.99. What is the ratio of the Area (% of total land area) of Arable land in 2004 to that in 2006?
Offer a terse response. 0.99. What is the ratio of the Area (% of total land area) in Permanent crop land in 2004 to that in 2006?
Your answer should be compact. 0.98. What is the ratio of the Area (% of total land area) in Arable land in 2004 to that in 2007?
Your answer should be very brief. 0.99. What is the ratio of the Area (% of total land area) of Permanent crop land in 2004 to that in 2007?
Offer a terse response. 0.97. What is the ratio of the Area (% of total land area) in Terrestrial protected areas in 2005 to that in 2006?
Your answer should be compact. 1. What is the ratio of the Area (% of total land area) of Agricultural land in 2005 to that in 2006?
Keep it short and to the point. 1. What is the ratio of the Area (% of total land area) of Arable land in 2005 to that in 2006?
Your answer should be compact. 1. What is the ratio of the Area (% of total land area) of Permanent crop land in 2005 to that in 2006?
Give a very brief answer. 0.99. What is the ratio of the Area (% of total land area) of Terrestrial protected areas in 2005 to that in 2007?
Provide a succinct answer. 1. What is the ratio of the Area (% of total land area) in Agricultural land in 2005 to that in 2007?
Offer a terse response. 1. What is the ratio of the Area (% of total land area) of Arable land in 2005 to that in 2007?
Provide a short and direct response. 1. What is the ratio of the Area (% of total land area) in Permanent crop land in 2005 to that in 2007?
Give a very brief answer. 0.98. What is the ratio of the Area (% of total land area) of Terrestrial protected areas in 2006 to that in 2007?
Keep it short and to the point. 1. What is the ratio of the Area (% of total land area) of Agricultural land in 2006 to that in 2007?
Provide a succinct answer. 1. What is the ratio of the Area (% of total land area) in Arable land in 2006 to that in 2007?
Give a very brief answer. 1. What is the difference between the highest and the second highest Area (% of total land area) in Terrestrial protected areas?
Provide a succinct answer. 0. What is the difference between the highest and the second highest Area (% of total land area) in Agricultural land?
Your response must be concise. 0.01. What is the difference between the highest and the second highest Area (% of total land area) in Arable land?
Provide a succinct answer. 0. What is the difference between the highest and the second highest Area (% of total land area) in Permanent crop land?
Ensure brevity in your answer.  0. What is the difference between the highest and the lowest Area (% of total land area) of Terrestrial protected areas?
Provide a succinct answer. 0. What is the difference between the highest and the lowest Area (% of total land area) in Agricultural land?
Provide a short and direct response. 0.09. What is the difference between the highest and the lowest Area (% of total land area) of Arable land?
Keep it short and to the point. 0.05. What is the difference between the highest and the lowest Area (% of total land area) in Permanent crop land?
Make the answer very short. 0.04. 